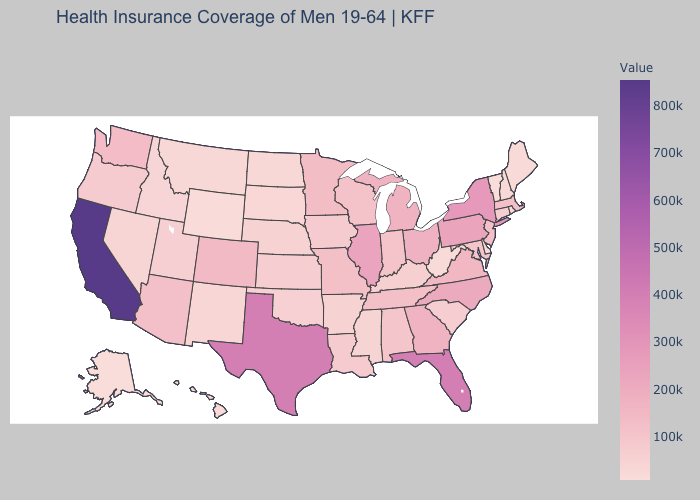Does California have the highest value in the USA?
Answer briefly. Yes. Does Georgia have a lower value than Texas?
Write a very short answer. Yes. Which states hav the highest value in the West?
Short answer required. California. Among the states that border Georgia , does North Carolina have the highest value?
Give a very brief answer. No. Does New Hampshire have the lowest value in the USA?
Answer briefly. No. 